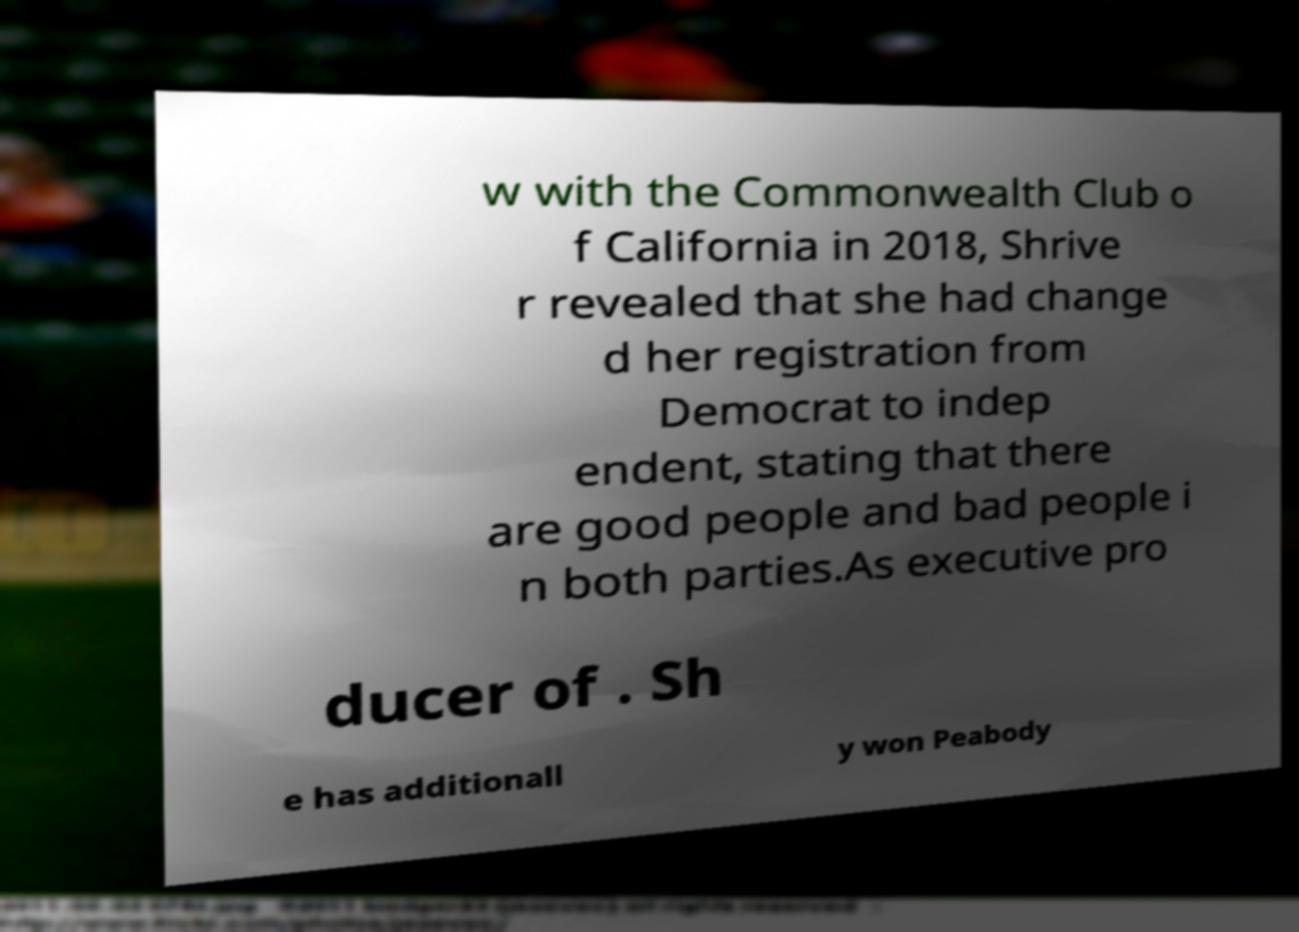Could you assist in decoding the text presented in this image and type it out clearly? w with the Commonwealth Club o f California in 2018, Shrive r revealed that she had change d her registration from Democrat to indep endent, stating that there are good people and bad people i n both parties.As executive pro ducer of . Sh e has additionall y won Peabody 